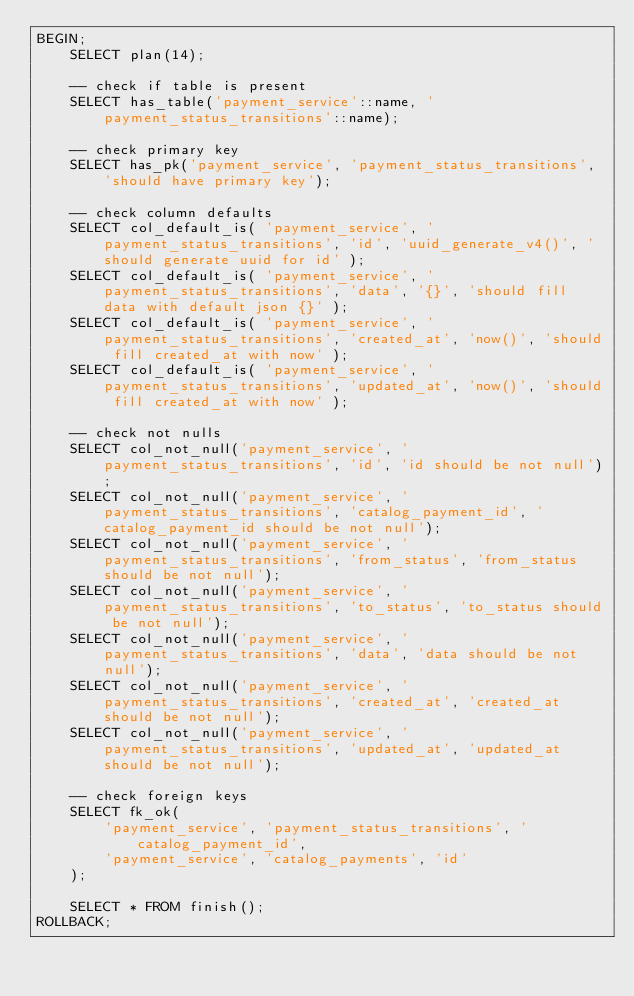Convert code to text. <code><loc_0><loc_0><loc_500><loc_500><_SQL_>BEGIN;
    SELECT plan(14);

    -- check if table is present
    SELECT has_table('payment_service'::name, 'payment_status_transitions'::name);

    -- check primary key
    SELECT has_pk('payment_service', 'payment_status_transitions', 'should have primary key');

    -- check column defaults
    SELECT col_default_is( 'payment_service', 'payment_status_transitions', 'id', 'uuid_generate_v4()', 'should generate uuid for id' );
    SELECT col_default_is( 'payment_service', 'payment_status_transitions', 'data', '{}', 'should fill data with default json {}' );
    SELECT col_default_is( 'payment_service', 'payment_status_transitions', 'created_at', 'now()', 'should fill created_at with now' );
    SELECT col_default_is( 'payment_service', 'payment_status_transitions', 'updated_at', 'now()', 'should fill created_at with now' );

    -- check not nulls
    SELECT col_not_null('payment_service', 'payment_status_transitions', 'id', 'id should be not null');
    SELECT col_not_null('payment_service', 'payment_status_transitions', 'catalog_payment_id', 'catalog_payment_id should be not null');
    SELECT col_not_null('payment_service', 'payment_status_transitions', 'from_status', 'from_status should be not null');
    SELECT col_not_null('payment_service', 'payment_status_transitions', 'to_status', 'to_status should be not null');
    SELECT col_not_null('payment_service', 'payment_status_transitions', 'data', 'data should be not null');
    SELECT col_not_null('payment_service', 'payment_status_transitions', 'created_at', 'created_at should be not null');
    SELECT col_not_null('payment_service', 'payment_status_transitions', 'updated_at', 'updated_at should be not null');

    -- check foreign keys
    SELECT fk_ok( 
        'payment_service', 'payment_status_transitions', 'catalog_payment_id',
        'payment_service', 'catalog_payments', 'id'
    );

    SELECT * FROM finish();
ROLLBACK;
</code> 